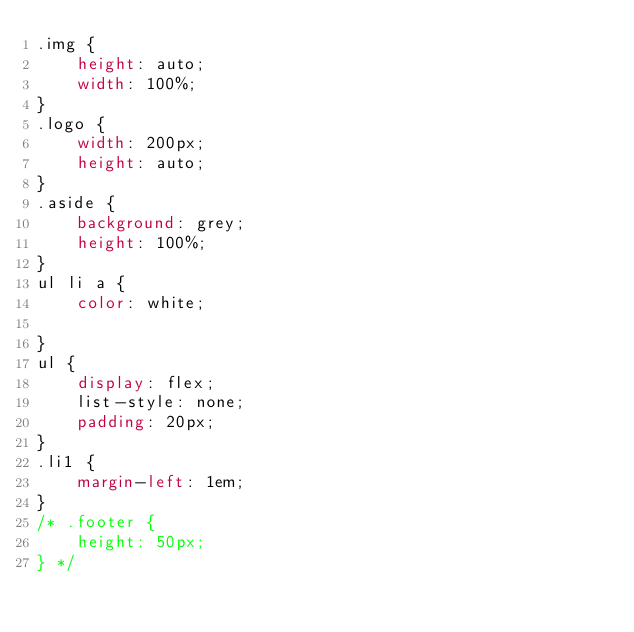Convert code to text. <code><loc_0><loc_0><loc_500><loc_500><_CSS_>.img {
    height: auto;
    width: 100%;
}
.logo {
    width: 200px;
    height: auto;
}
.aside {
    background: grey;
    height: 100%;
}
ul li a {
    color: white;   
   
}
ul {
    display: flex;
    list-style: none; 
    padding: 20px;
}
.li1 {
    margin-left: 1em;
}
/* .footer {
    height: 50px;
} */</code> 